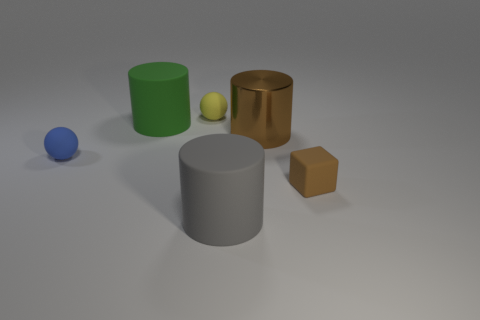How many other things are there of the same size as the yellow sphere?
Make the answer very short. 2. Is there a large purple cylinder?
Ensure brevity in your answer.  No. What size is the rubber cylinder that is behind the ball that is in front of the yellow thing?
Make the answer very short. Large. Do the large thing that is right of the gray matte cylinder and the big cylinder in front of the small blue sphere have the same color?
Provide a short and direct response. No. What color is the tiny thing that is both in front of the shiny thing and on the right side of the blue sphere?
Provide a short and direct response. Brown. How many other things are the same shape as the metallic object?
Your answer should be very brief. 2. There is another matte ball that is the same size as the yellow matte ball; what color is it?
Ensure brevity in your answer.  Blue. What color is the big cylinder that is on the right side of the gray matte thing?
Your answer should be compact. Brown. Are there any green cylinders that are in front of the matte cylinder that is behind the brown rubber object?
Ensure brevity in your answer.  No. There is a large brown shiny thing; is its shape the same as the small object that is behind the small blue rubber thing?
Provide a short and direct response. No. 